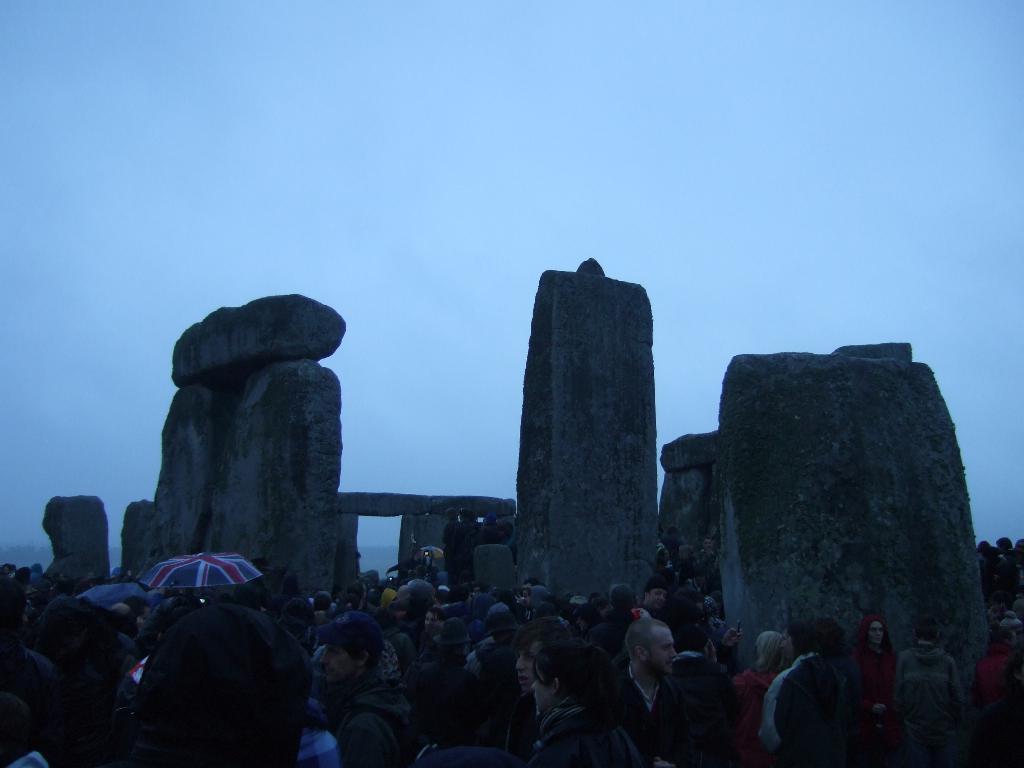Could you give a brief overview of what you see in this image? In this image we can see so many people, there are some rocks and umbrellas and in the background we can see the sky. 